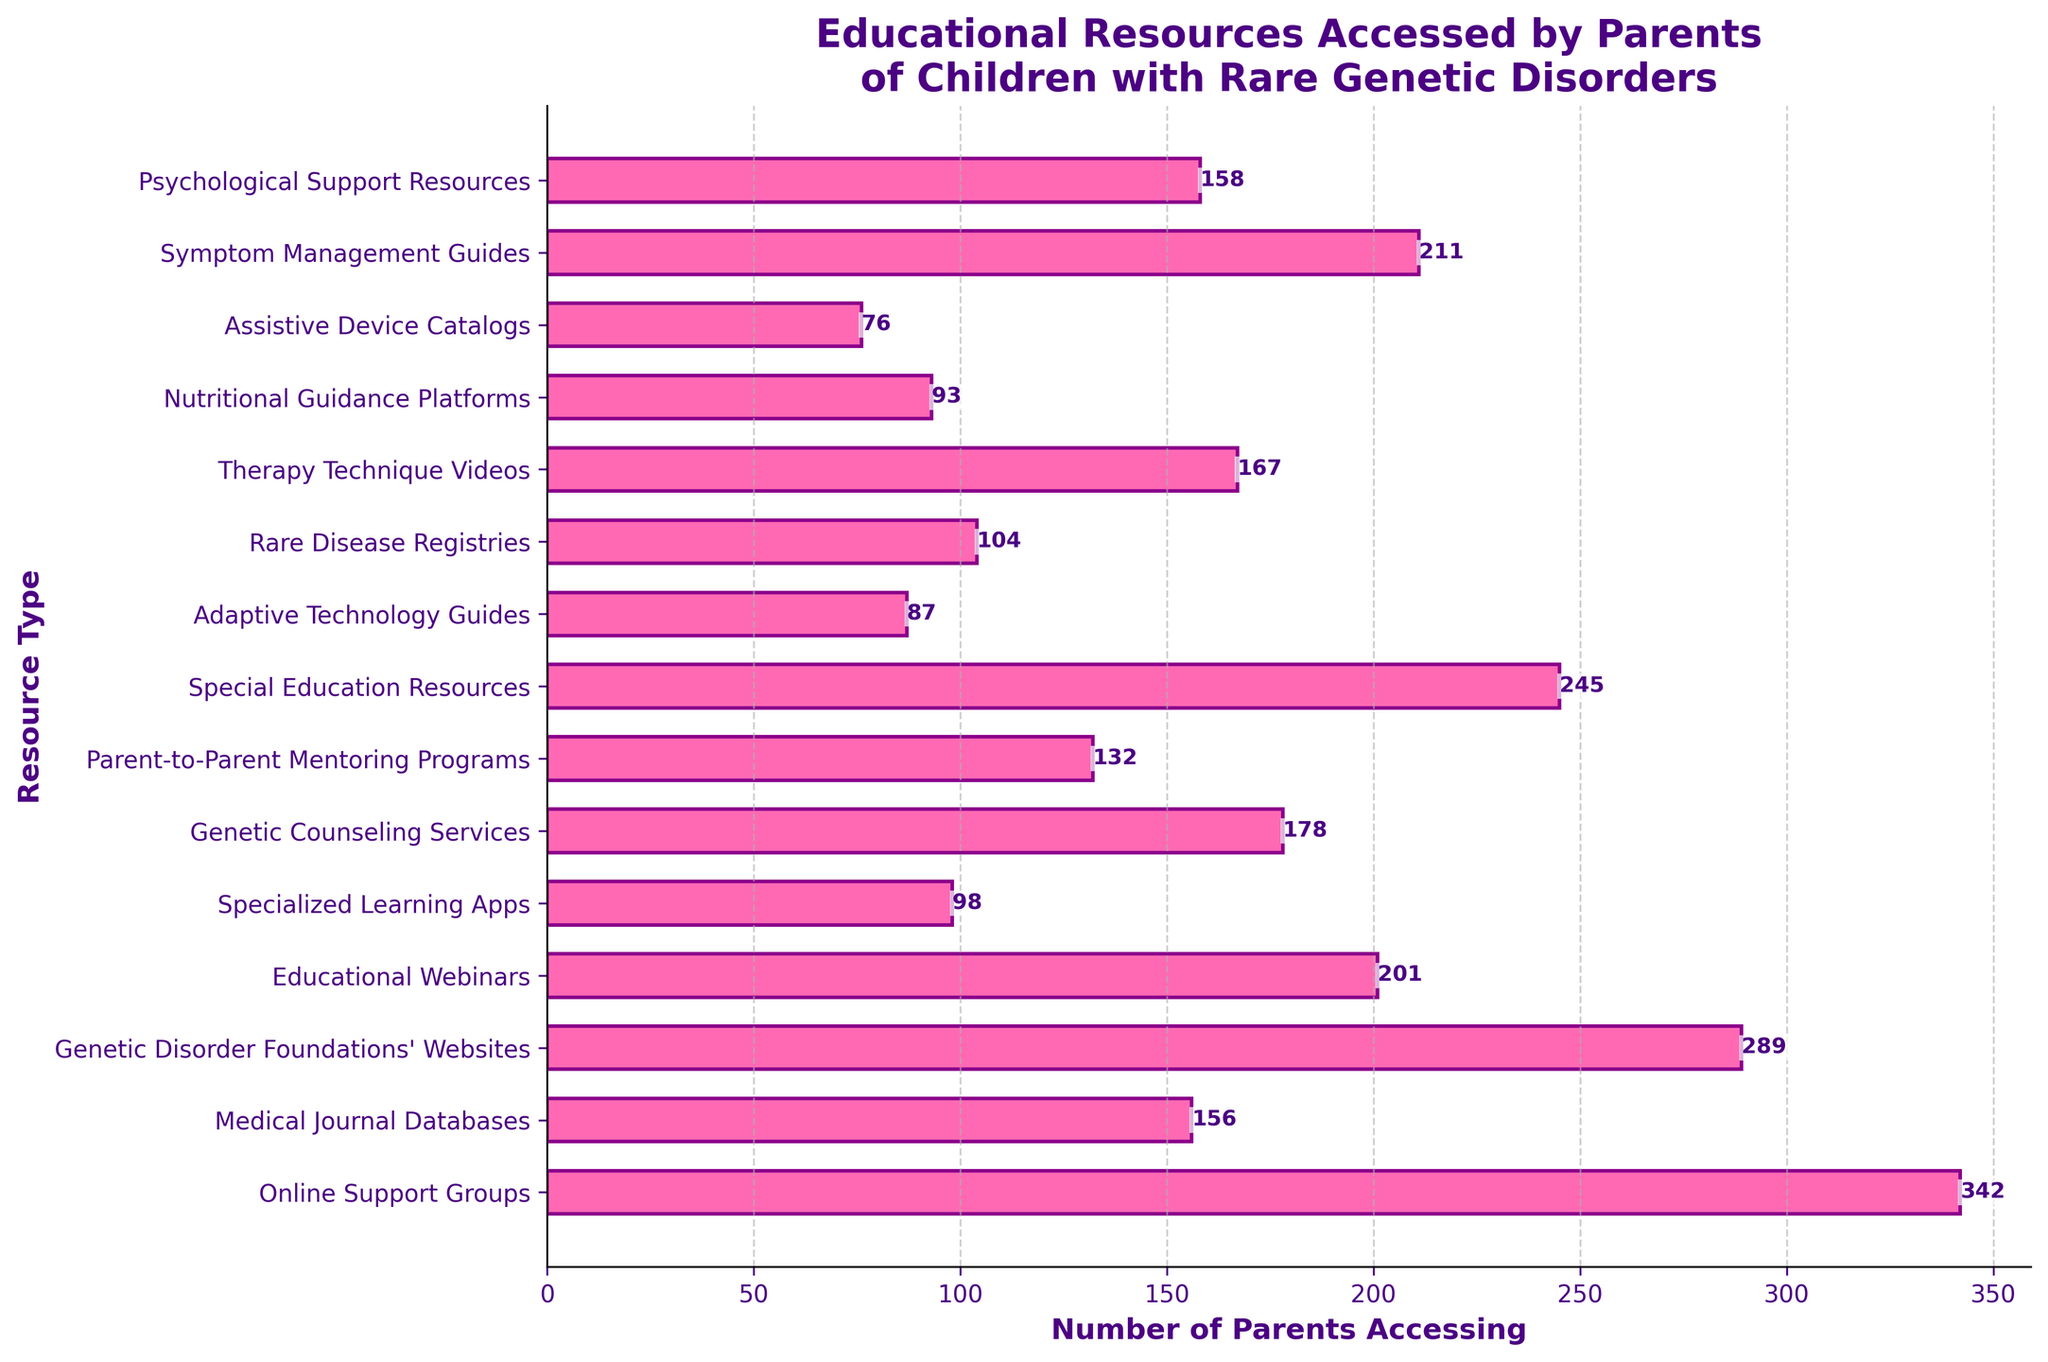Which resource type is accessed by the highest number of parents? The resource type accessed by the highest number of parents can be identified by finding the longest bar in the bar chart. The longest bar corresponds to "Online Support Groups."
Answer: Online Support Groups Which resource type is accessed by the least number of parents? The resource type accessed by the least number of parents can be identified by finding the shortest bar in the bar chart. The shortest bar corresponds to "Assistive Device Catalogs."
Answer: Assistive Device Catalogs How many more parents accessed Special Education Resources compared to Specialized Learning Apps? To find how many more parents accessed Special Education Resources compared to Specialized Learning Apps, subtract the number of parents accessing Specialized Learning Apps (98) from the number accessing Special Education Resources (245). 245 - 98 = 147
Answer: 147 What's the average number of parents accessing Genetic Counseling Services, Therapy Technique Videos, and Psychological Support Resources? To find the average number of parents accessing these resources, add the number of parents accessing each resource and divide by the number of resources: (178 + 167 + 158) / 3 = 503 / 3 = 167.67
Answer: 167.67 Which resources are accessed by more than 200 parents? To identify resources accessed by more than 200 parents, look for bars that extend beyond the 200 mark on the x-axis. These resources are "Online Support Groups," "Genetic Disorder Foundations' Websites," "Educational Webinars," "Special Education Resources," and "Symptom Management Guides."
Answer: Online Support Groups, Genetic Disorder Foundations' Websites, Educational Webinars, Special Education Resources, Symptom Management Guides By how much does the number of parents accessing Nutritional Guidance Platforms fall short of those accessing Adaptive Technology Guides? To determine this, subtract the number of parents accessing Nutritional Guidance Platforms (93) from those accessing Adaptive Technology Guides (87). 87 - 93 = -6, indicating where Nutritional Guidance Platforms actually exceed by 6.
Answer: 6 How many parents in total accessed Medical Journal Databases, Rare Disease Registries, and Assistive Device Catalogs? To find the total number, add the number of parents accessing each of these resources: 156 (Medical Journal Databases) + 104 (Rare Disease Registries) + 76 (Assistive Device Catalogs) = 336
Answer: 336 Which resource type is accessed by a number of parents closest to the median value of all given resources? First, list the number of parents accessing each resource and find the median value: [76, 87, 93, 98, 104, 132, 156, 158, 167, 178, 201, 211, 245, 289, 342]. The median is 158 (middle value). The resource type accessed by 158 parents is "Psychological Support Resources."
Answer: Psychological Support Resources 